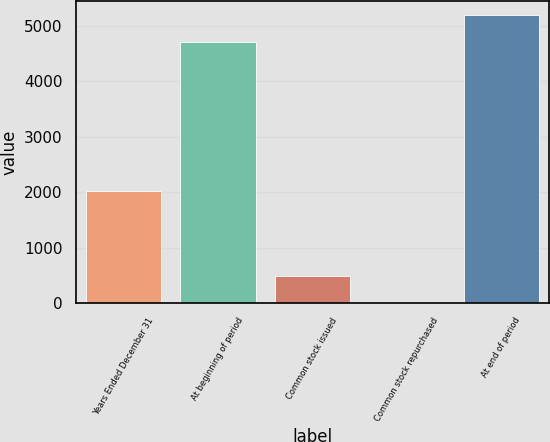<chart> <loc_0><loc_0><loc_500><loc_500><bar_chart><fcel>Years Ended December 31<fcel>At beginning of period<fcel>Common stock issued<fcel>Common stock repurchased<fcel>At end of period<nl><fcel>2014<fcel>4715<fcel>483.7<fcel>7<fcel>5191.7<nl></chart> 